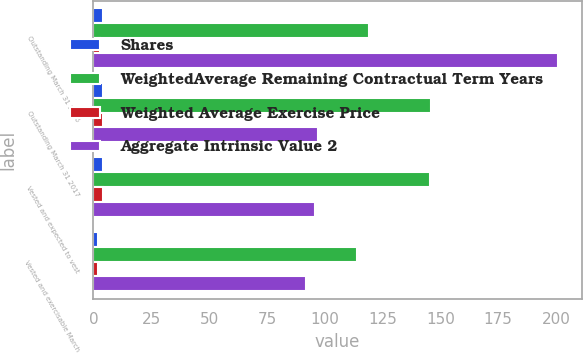Convert chart to OTSL. <chart><loc_0><loc_0><loc_500><loc_500><stacked_bar_chart><ecel><fcel>Outstanding March 31 2016<fcel>Outstanding March 31 2017<fcel>Vested and expected to vest<fcel>Vested and exercisable March<nl><fcel>Shares<fcel>4<fcel>4<fcel>4<fcel>2<nl><fcel>WeightedAverage Remaining Contractual Term Years<fcel>118.95<fcel>145.76<fcel>145.54<fcel>114<nl><fcel>Weighted Average Exercise Price<fcel>3<fcel>4<fcel>4<fcel>2<nl><fcel>Aggregate Intrinsic Value 2<fcel>201<fcel>97<fcel>96<fcel>92<nl></chart> 